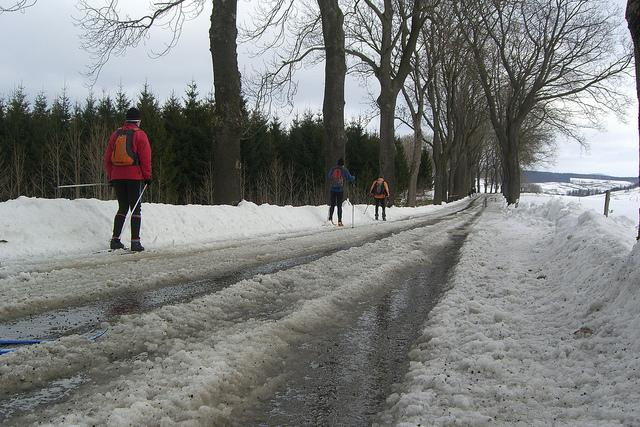What caused the deepest mushiest tracks here? car 